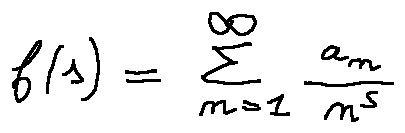<formula> <loc_0><loc_0><loc_500><loc_500>f ( s ) = \sum \lim i t s _ { n = 1 } ^ { \infty } \frac { a _ { n } } { n ^ { s } }</formula> 